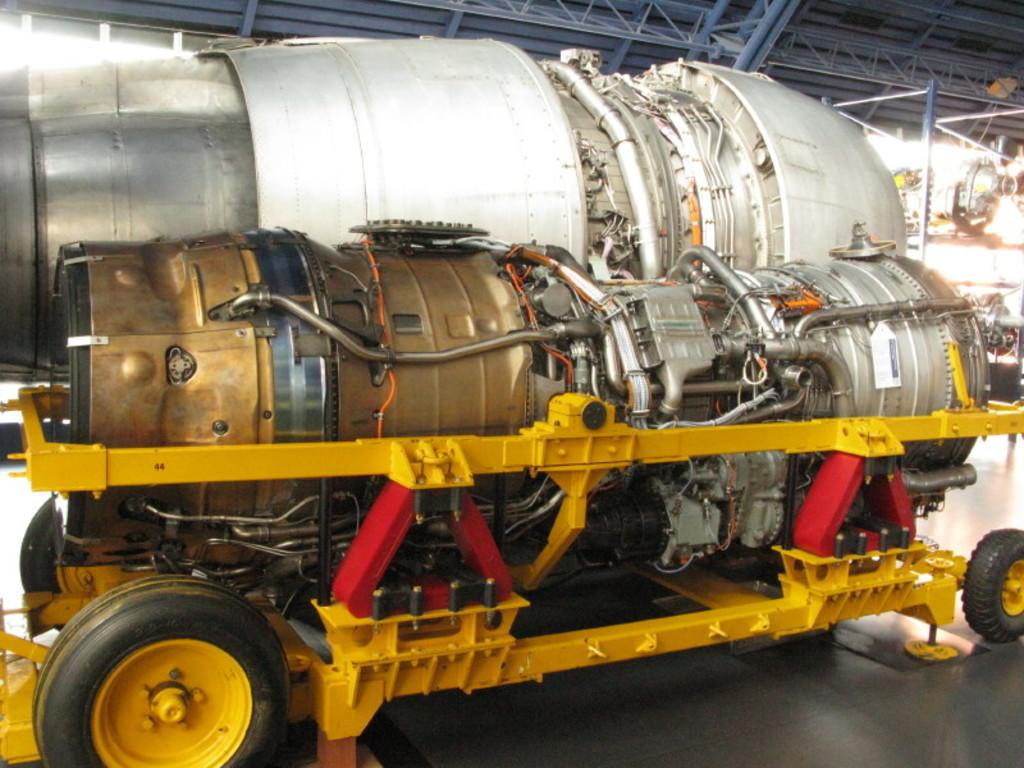What type of machinery is present in the image? There are motors in the image. What is the main subject of the image? There is a vehicle in the image. What feature of the vehicle allows it to move? The vehicle has wheels. What type of cap is the vehicle wearing in the image? There is no cap present on the vehicle in the image. Is there a pipe visible in the image? There is no pipe present in the image. 